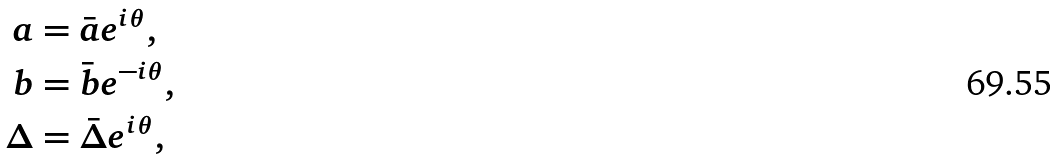<formula> <loc_0><loc_0><loc_500><loc_500>a & = \bar { a } e ^ { i \theta } , \\ b & = \bar { b } e ^ { - i \theta } , \\ \Delta & = \bar { \Delta } e ^ { i \theta } ,</formula> 